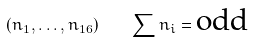<formula> <loc_0><loc_0><loc_500><loc_500>\left ( n _ { 1 } , \dots , n _ { 1 6 } \right ) \quad \sum n _ { i } = \text {odd}</formula> 